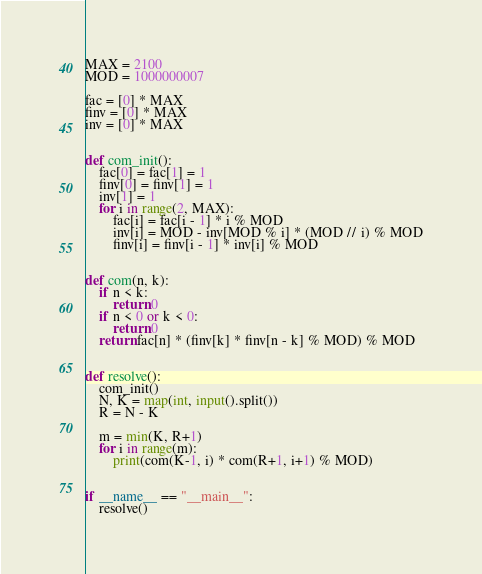Convert code to text. <code><loc_0><loc_0><loc_500><loc_500><_Python_>MAX = 2100
MOD = 1000000007

fac = [0] * MAX
finv = [0] * MAX
inv = [0] * MAX


def com_init():
    fac[0] = fac[1] = 1
    finv[0] = finv[1] = 1
    inv[1] = 1
    for i in range(2, MAX):
        fac[i] = fac[i - 1] * i % MOD
        inv[i] = MOD - inv[MOD % i] * (MOD // i) % MOD
        finv[i] = finv[i - 1] * inv[i] % MOD


def com(n, k):
    if n < k:
        return 0
    if n < 0 or k < 0:
        return 0
    return fac[n] * (finv[k] * finv[n - k] % MOD) % MOD


def resolve():
    com_init()
    N, K = map(int, input().split())
    R = N - K

    m = min(K, R+1)
    for i in range(m):
        print(com(K-1, i) * com(R+1, i+1) % MOD)
        

if __name__ == "__main__":
    resolve()</code> 